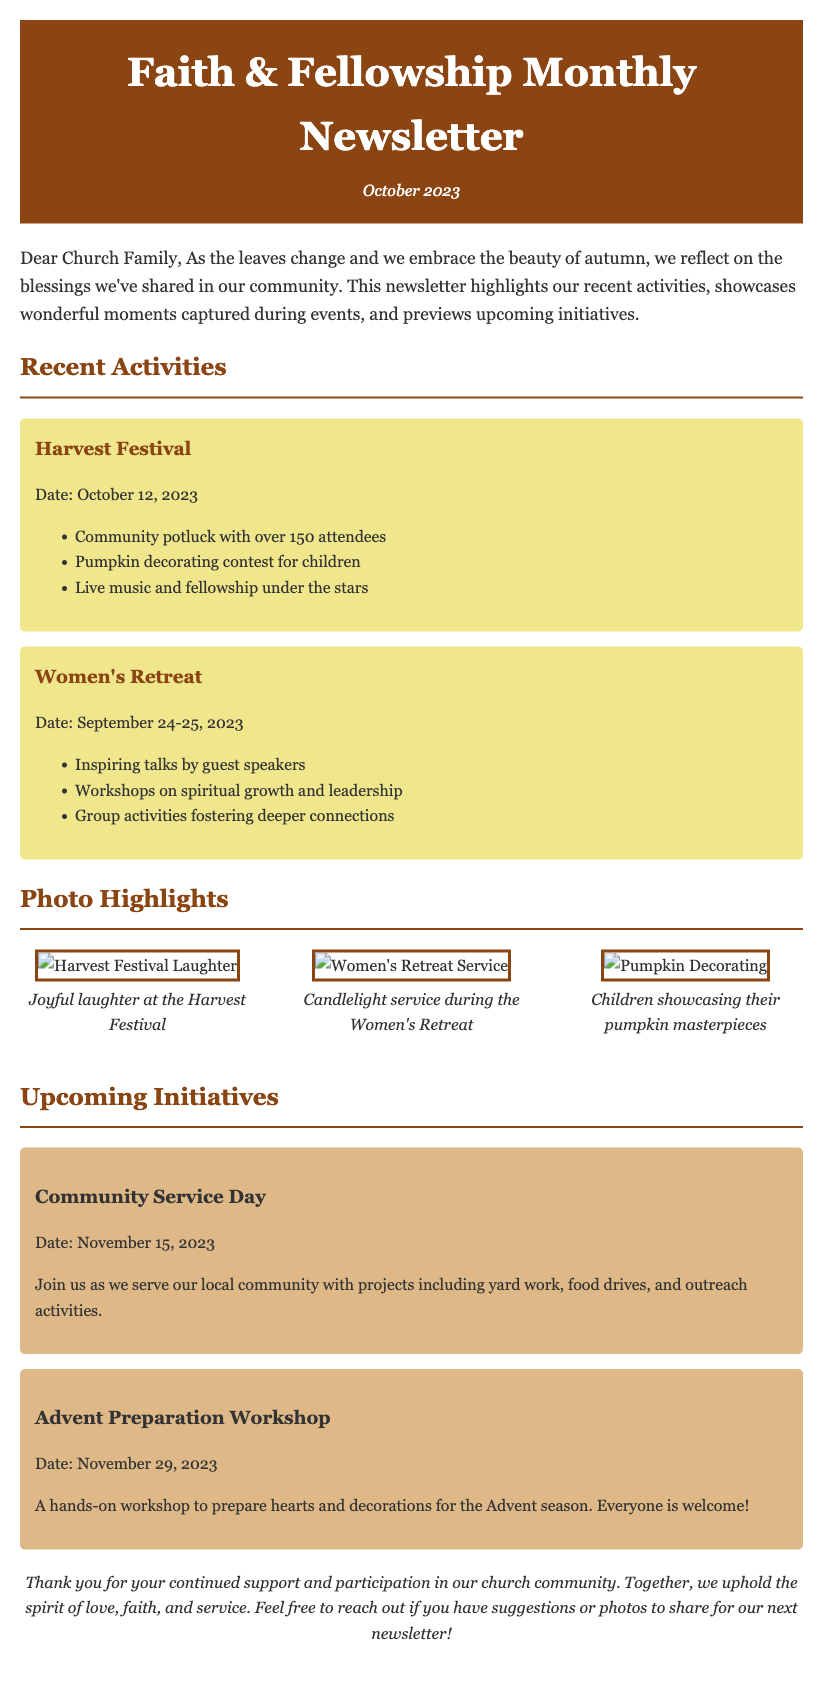What is the title of the newsletter? The title of the newsletter is presented prominently at the top of the document.
Answer: Faith & Fellowship Monthly Newsletter What month is this newsletter for? The date at the top of the newsletter indicates the specific month covered.
Answer: October 2023 What event took place on October 12, 2023? The document lists events with their corresponding dates, revealing this specific gathering.
Answer: Harvest Festival How many attendees were at the Harvest Festival? The newsletter mentions the number of people who attended the event.
Answer: over 150 attendees What is one activity listed for the Women's Retreat? The document lists activities for the event, highlighting what participants experienced.
Answer: Inspiring talks by guest speakers What is the date for the Community Service Day? The upcoming initiative section provides the date for this service event.
Answer: November 15, 2023 What type of workshop will be held on November 29, 2023? The upcoming initiatives detail the nature of the event scheduled on this date.
Answer: Advent Preparation Workshop What is the overall theme of the newsletter? The introduction provides insight into the general tone and messaging for the community.
Answer: Community activities and fellowship What should members do if they have suggestions for the next newsletter? The closing remarks indicate a call to action for readers to engage further.
Answer: Reach out 